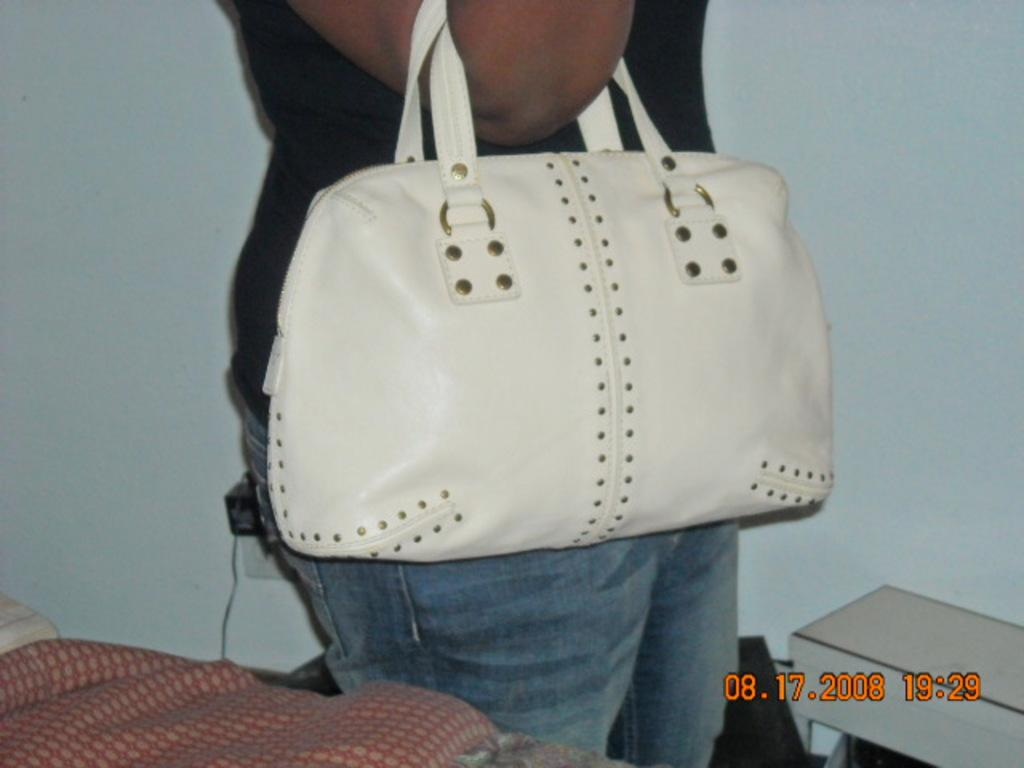What can be seen in the background of the image? There is a wall in the image. Who is present in the image? There is a woman in the image. What is the woman holding in the image? The woman is holding a white-colored handbag. Can you tell me how many fowls are present in the image? There are no fowls present in the image; it only features a woman holding a white-colored handbag in front of a wall. What type of sack is the woman carrying in the image? The woman is not carrying a sack in the image; she is holding a white-colored handbag. 